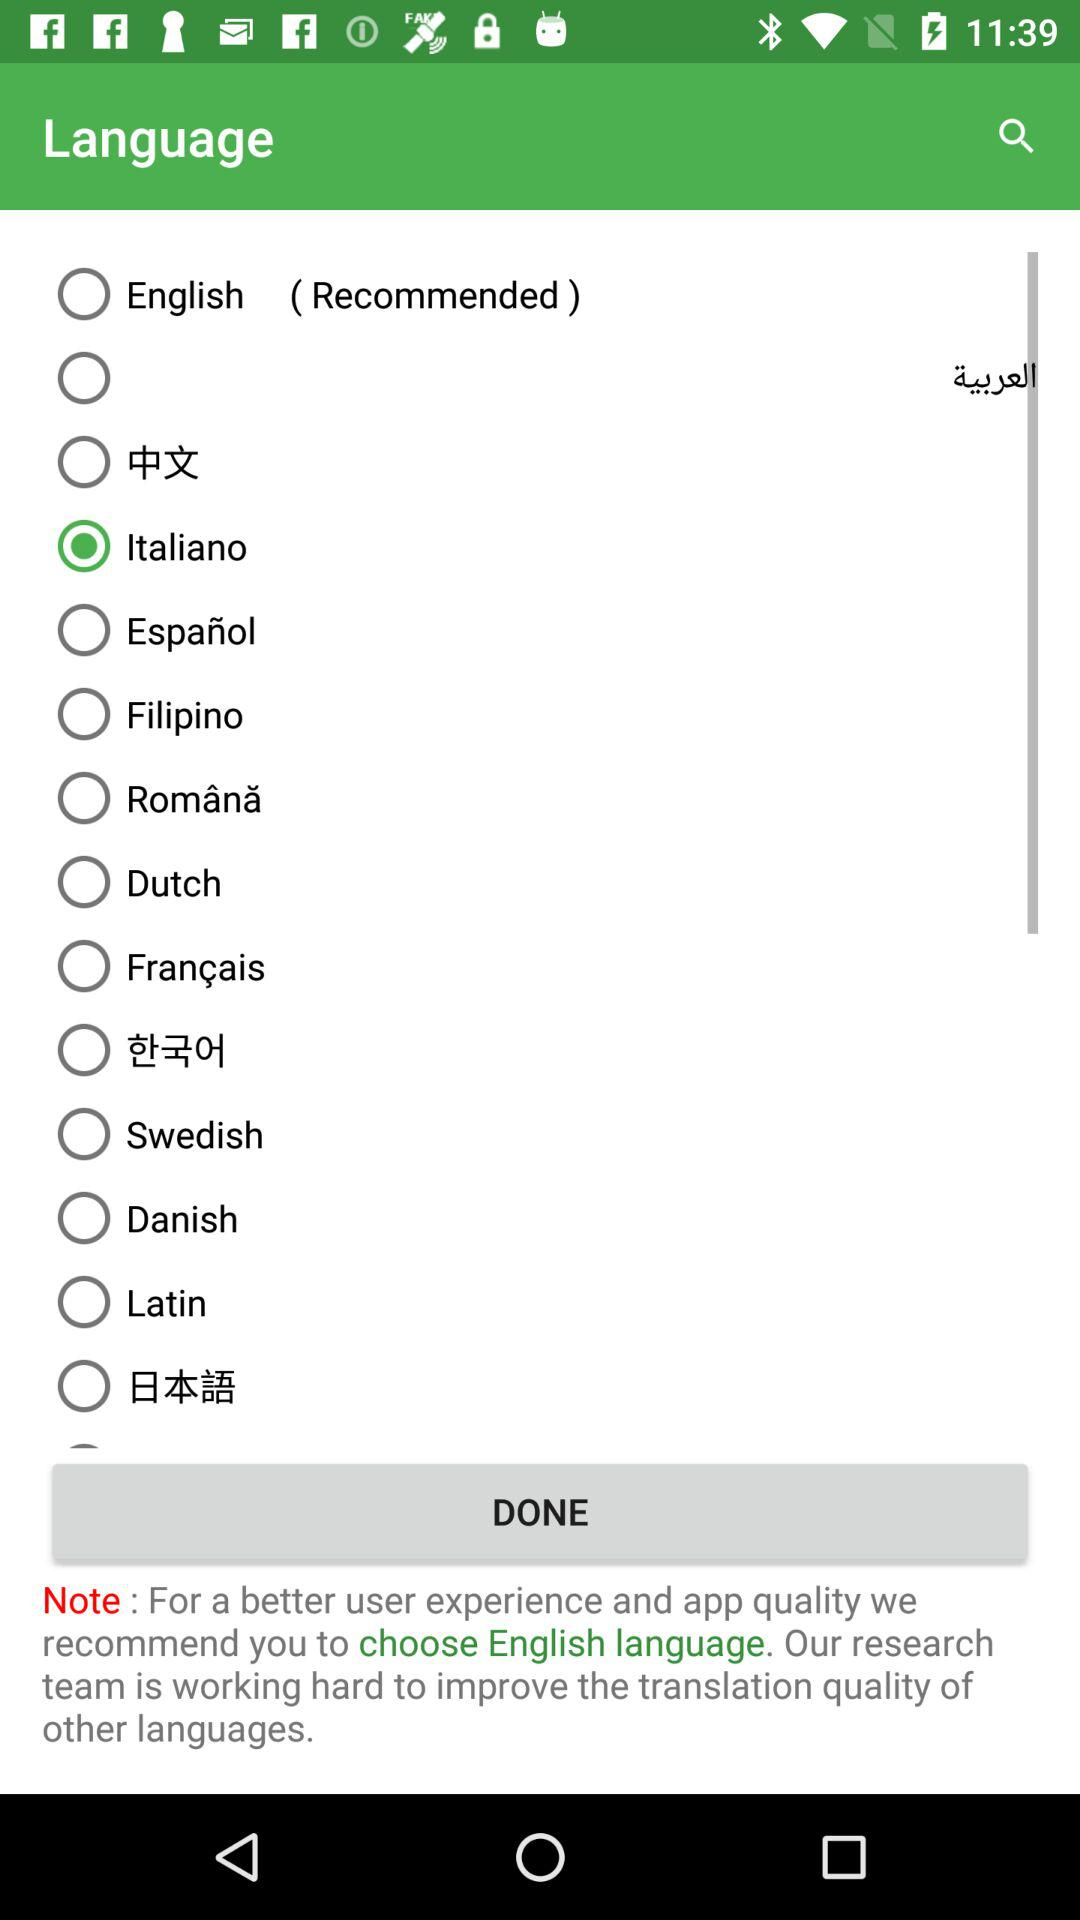Which option is selected? The selected option is "Italiano". 